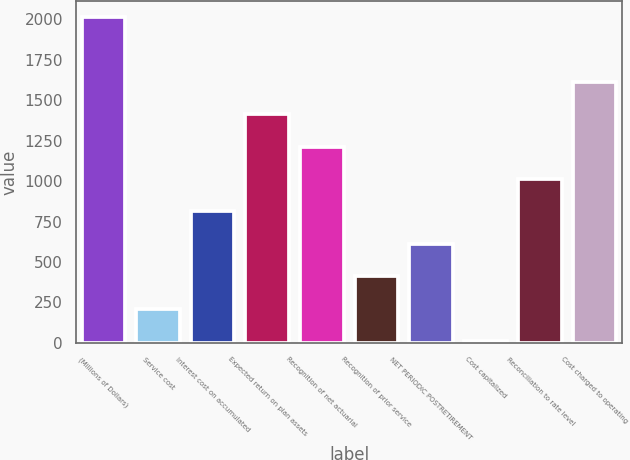Convert chart to OTSL. <chart><loc_0><loc_0><loc_500><loc_500><bar_chart><fcel>(Millions of Dollars)<fcel>Service cost<fcel>Interest cost on accumulated<fcel>Expected return on plan assets<fcel>Recognition of net actuarial<fcel>Recognition of prior service<fcel>NET PERIODIC POSTRETIREMENT<fcel>Cost capitalized<fcel>Reconciliation to rate level<fcel>Cost charged to operating<nl><fcel>2013<fcel>212.1<fcel>812.4<fcel>1412.7<fcel>1212.6<fcel>412.2<fcel>612.3<fcel>12<fcel>1012.5<fcel>1612.8<nl></chart> 